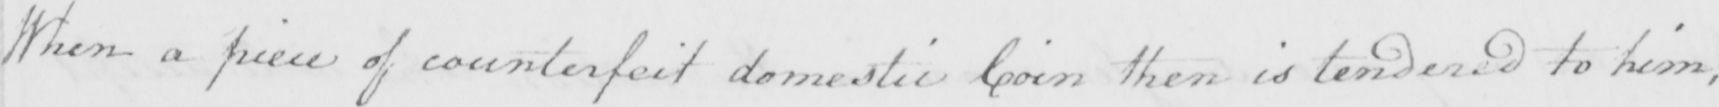Please transcribe the handwritten text in this image. When a piece of counterfeit domestic Coin then is tendered to him , 